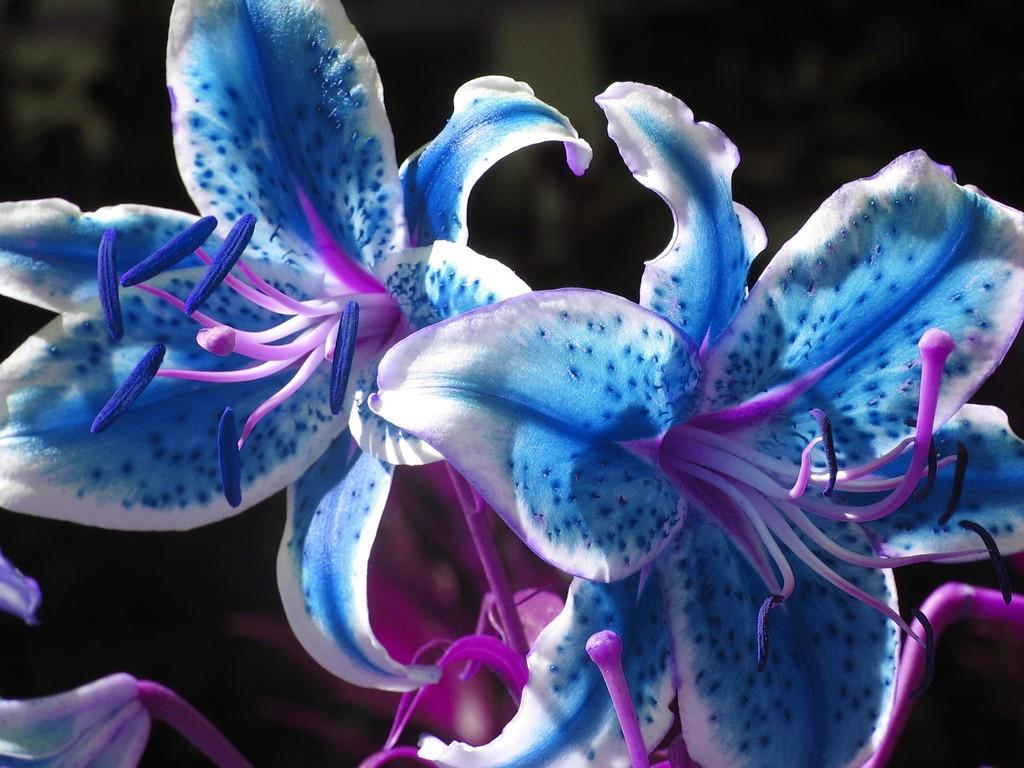Can you describe this image briefly? In this image we can see the blue color flowers. The background of the image is dark. 